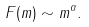Convert formula to latex. <formula><loc_0><loc_0><loc_500><loc_500>F ( m ) \sim m ^ { \alpha } .</formula> 